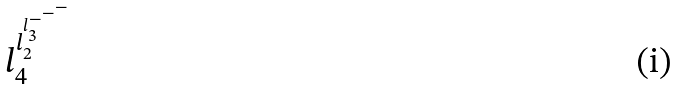<formula> <loc_0><loc_0><loc_500><loc_500>l _ { 4 } ^ { l _ { 2 } ^ { l _ { 3 } ^ { - ^ { - ^ { - } } } } }</formula> 